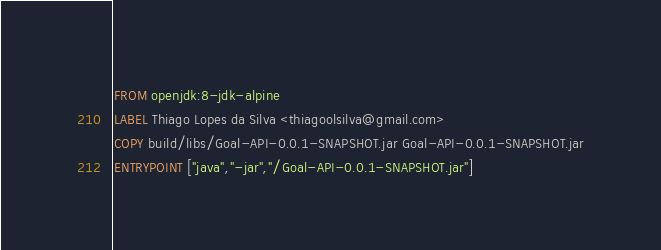<code> <loc_0><loc_0><loc_500><loc_500><_Dockerfile_>FROM openjdk:8-jdk-alpine
LABEL Thiago Lopes da Silva <thiagoolsilva@gmail.com>
COPY build/libs/Goal-API-0.0.1-SNAPSHOT.jar Goal-API-0.0.1-SNAPSHOT.jar
ENTRYPOINT ["java","-jar","/Goal-API-0.0.1-SNAPSHOT.jar"]</code> 